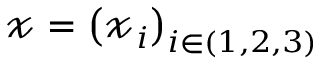Convert formula to latex. <formula><loc_0><loc_0><loc_500><loc_500>\ m a t h s c r { x } = \left ( \ m a t h s c r { x } _ { i } \right ) _ { i \in ( 1 , 2 , 3 ) }</formula> 